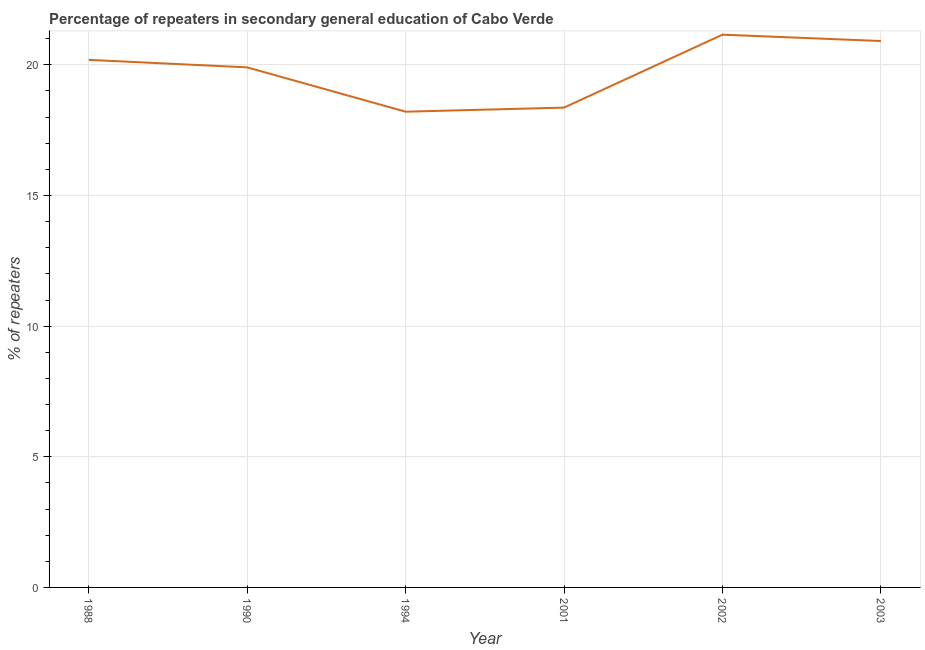What is the percentage of repeaters in 1988?
Ensure brevity in your answer.  20.19. Across all years, what is the maximum percentage of repeaters?
Your response must be concise. 21.16. Across all years, what is the minimum percentage of repeaters?
Offer a very short reply. 18.21. In which year was the percentage of repeaters maximum?
Give a very brief answer. 2002. In which year was the percentage of repeaters minimum?
Give a very brief answer. 1994. What is the sum of the percentage of repeaters?
Give a very brief answer. 118.74. What is the difference between the percentage of repeaters in 1990 and 1994?
Make the answer very short. 1.7. What is the average percentage of repeaters per year?
Offer a terse response. 19.79. What is the median percentage of repeaters?
Give a very brief answer. 20.05. Do a majority of the years between 1990 and 2001 (inclusive) have percentage of repeaters greater than 11 %?
Ensure brevity in your answer.  Yes. What is the ratio of the percentage of repeaters in 1988 to that in 2003?
Your answer should be compact. 0.97. What is the difference between the highest and the second highest percentage of repeaters?
Your response must be concise. 0.24. What is the difference between the highest and the lowest percentage of repeaters?
Offer a terse response. 2.95. What is the difference between two consecutive major ticks on the Y-axis?
Ensure brevity in your answer.  5. Does the graph contain any zero values?
Offer a terse response. No. Does the graph contain grids?
Provide a short and direct response. Yes. What is the title of the graph?
Keep it short and to the point. Percentage of repeaters in secondary general education of Cabo Verde. What is the label or title of the X-axis?
Ensure brevity in your answer.  Year. What is the label or title of the Y-axis?
Your response must be concise. % of repeaters. What is the % of repeaters of 1988?
Offer a terse response. 20.19. What is the % of repeaters of 1990?
Give a very brief answer. 19.9. What is the % of repeaters of 1994?
Keep it short and to the point. 18.21. What is the % of repeaters in 2001?
Your answer should be compact. 18.36. What is the % of repeaters in 2002?
Give a very brief answer. 21.16. What is the % of repeaters of 2003?
Give a very brief answer. 20.91. What is the difference between the % of repeaters in 1988 and 1990?
Offer a terse response. 0.29. What is the difference between the % of repeaters in 1988 and 1994?
Your answer should be very brief. 1.98. What is the difference between the % of repeaters in 1988 and 2001?
Keep it short and to the point. 1.83. What is the difference between the % of repeaters in 1988 and 2002?
Your answer should be very brief. -0.96. What is the difference between the % of repeaters in 1988 and 2003?
Provide a succinct answer. -0.72. What is the difference between the % of repeaters in 1990 and 1994?
Provide a short and direct response. 1.7. What is the difference between the % of repeaters in 1990 and 2001?
Offer a very short reply. 1.54. What is the difference between the % of repeaters in 1990 and 2002?
Keep it short and to the point. -1.25. What is the difference between the % of repeaters in 1990 and 2003?
Offer a very short reply. -1.01. What is the difference between the % of repeaters in 1994 and 2001?
Give a very brief answer. -0.16. What is the difference between the % of repeaters in 1994 and 2002?
Your answer should be compact. -2.95. What is the difference between the % of repeaters in 1994 and 2003?
Make the answer very short. -2.7. What is the difference between the % of repeaters in 2001 and 2002?
Your answer should be compact. -2.79. What is the difference between the % of repeaters in 2001 and 2003?
Your answer should be compact. -2.55. What is the difference between the % of repeaters in 2002 and 2003?
Your answer should be very brief. 0.24. What is the ratio of the % of repeaters in 1988 to that in 1990?
Ensure brevity in your answer.  1.01. What is the ratio of the % of repeaters in 1988 to that in 1994?
Keep it short and to the point. 1.11. What is the ratio of the % of repeaters in 1988 to that in 2002?
Make the answer very short. 0.95. What is the ratio of the % of repeaters in 1988 to that in 2003?
Offer a terse response. 0.97. What is the ratio of the % of repeaters in 1990 to that in 1994?
Your answer should be very brief. 1.09. What is the ratio of the % of repeaters in 1990 to that in 2001?
Give a very brief answer. 1.08. What is the ratio of the % of repeaters in 1990 to that in 2002?
Ensure brevity in your answer.  0.94. What is the ratio of the % of repeaters in 1990 to that in 2003?
Offer a very short reply. 0.95. What is the ratio of the % of repeaters in 1994 to that in 2002?
Make the answer very short. 0.86. What is the ratio of the % of repeaters in 1994 to that in 2003?
Provide a succinct answer. 0.87. What is the ratio of the % of repeaters in 2001 to that in 2002?
Offer a terse response. 0.87. What is the ratio of the % of repeaters in 2001 to that in 2003?
Give a very brief answer. 0.88. What is the ratio of the % of repeaters in 2002 to that in 2003?
Your answer should be compact. 1.01. 